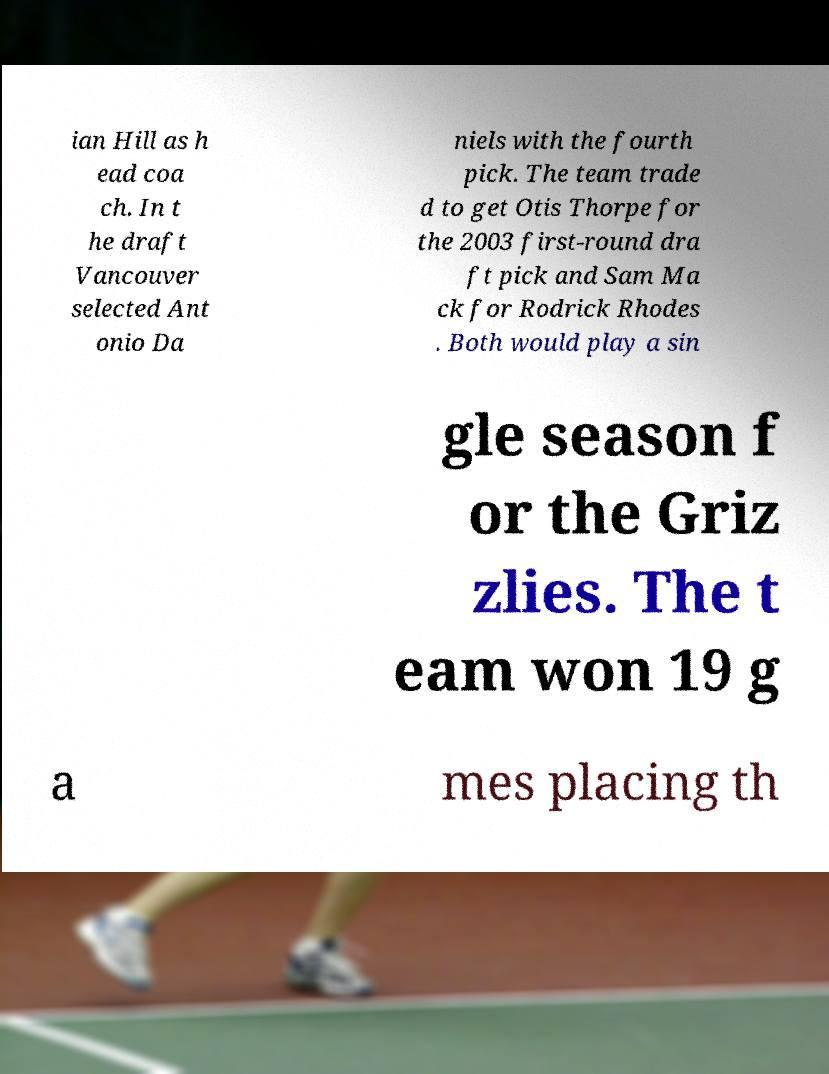Please read and relay the text visible in this image. What does it say? ian Hill as h ead coa ch. In t he draft Vancouver selected Ant onio Da niels with the fourth pick. The team trade d to get Otis Thorpe for the 2003 first-round dra ft pick and Sam Ma ck for Rodrick Rhodes . Both would play a sin gle season f or the Griz zlies. The t eam won 19 g a mes placing th 